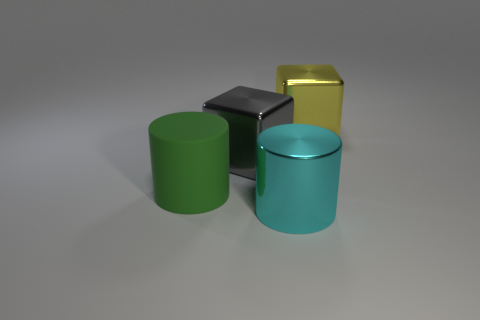Is there any other thing that has the same color as the metallic cylinder?
Your answer should be very brief. No. There is a big thing right of the large cyan cylinder; what shape is it?
Give a very brief answer. Cube. There is a big metallic cylinder; is it the same color as the big metal block in front of the big yellow metallic block?
Your answer should be compact. No. Are there the same number of large cylinders on the left side of the large rubber cylinder and blocks that are behind the big cyan cylinder?
Keep it short and to the point. No. How many other objects are the same size as the cyan metallic thing?
Your answer should be very brief. 3. What size is the gray thing?
Give a very brief answer. Large. Is the big gray block made of the same material as the cylinder that is right of the big rubber thing?
Keep it short and to the point. Yes. Is there a large green thing of the same shape as the cyan shiny object?
Provide a succinct answer. Yes. There is a green cylinder that is the same size as the gray object; what material is it?
Give a very brief answer. Rubber. There is a cube that is to the left of the big yellow block; what size is it?
Ensure brevity in your answer.  Large. 